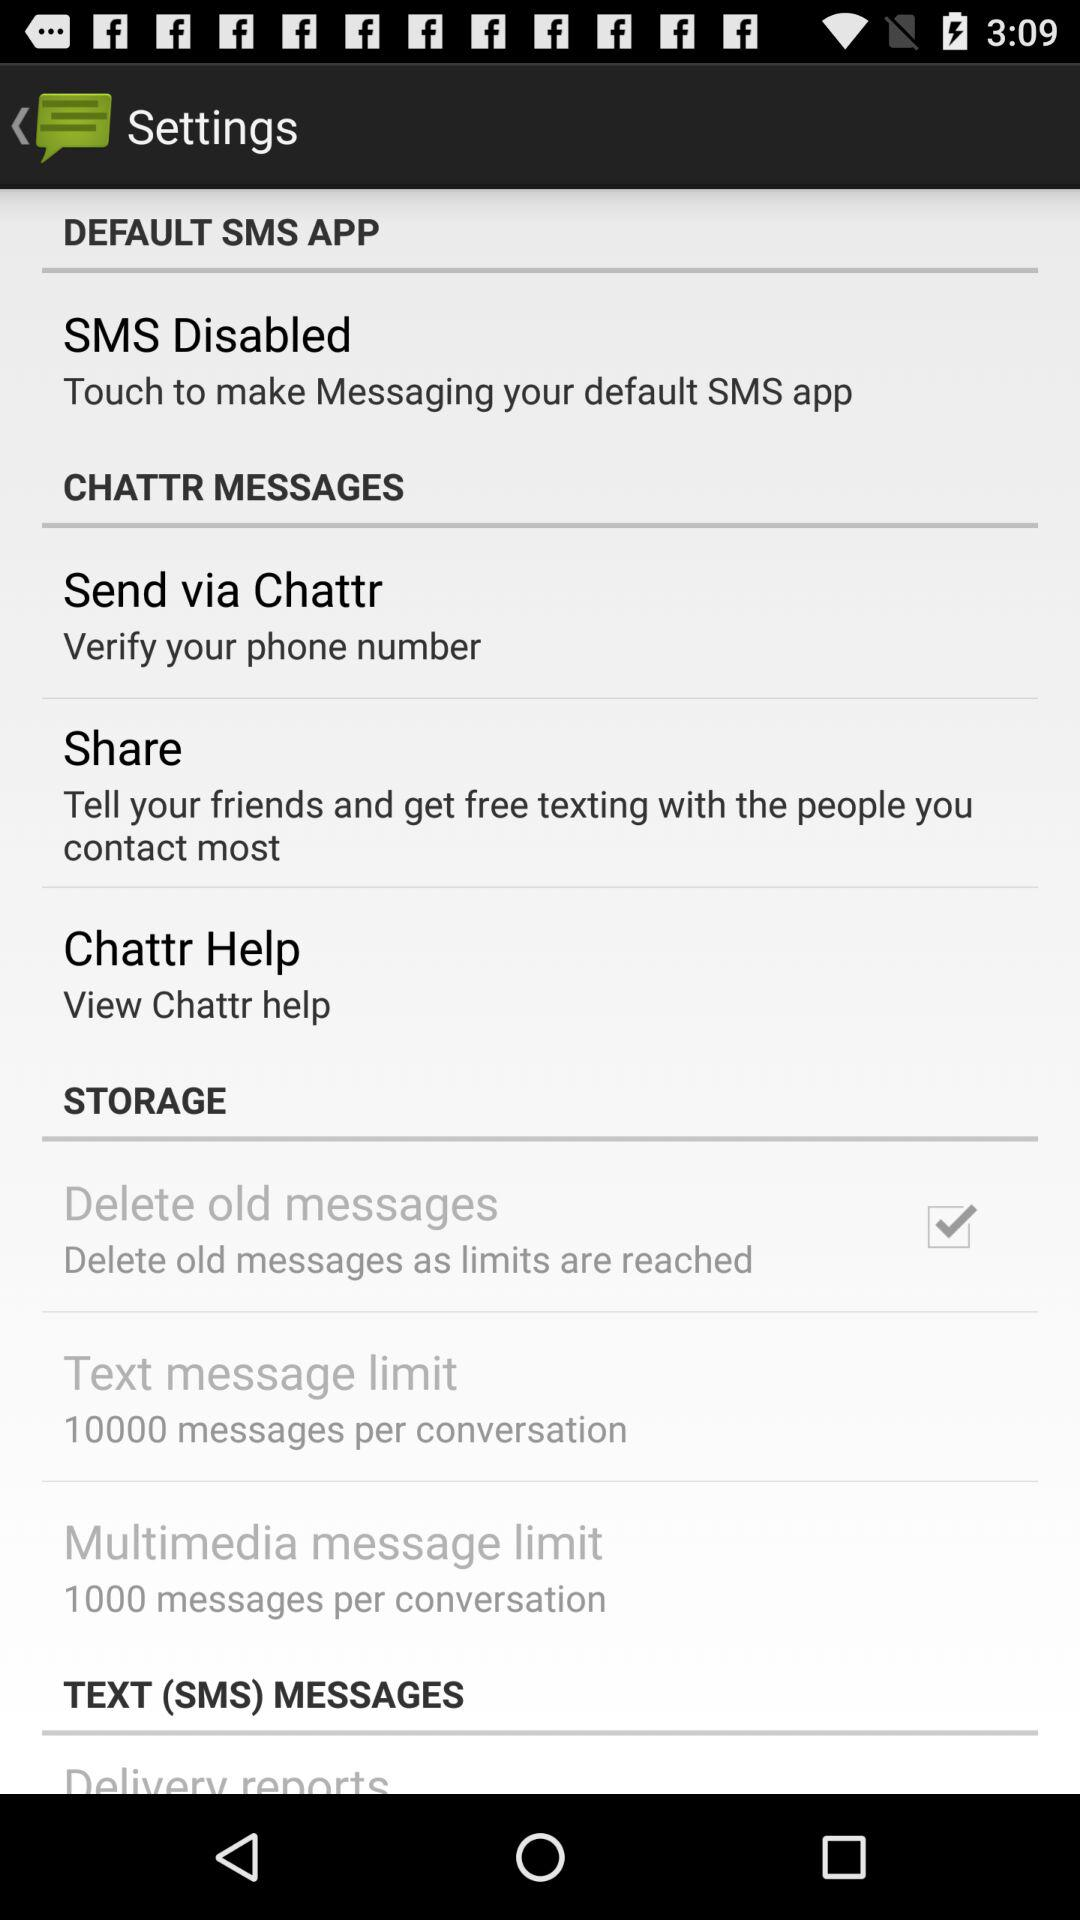What is the status of "Delete old messages"? The status of "Delete old messages" is "on". 